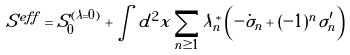<formula> <loc_0><loc_0><loc_500><loc_500>S ^ { e f f } = S _ { 0 } ^ { ( \lambda = 0 ) } + \int d ^ { 2 } x \sum _ { n \geq 1 } \lambda _ { n } ^ { * } \left ( - \dot { \sigma } _ { n } + ( - 1 ) ^ { n } \sigma _ { n } ^ { \prime } \right )</formula> 